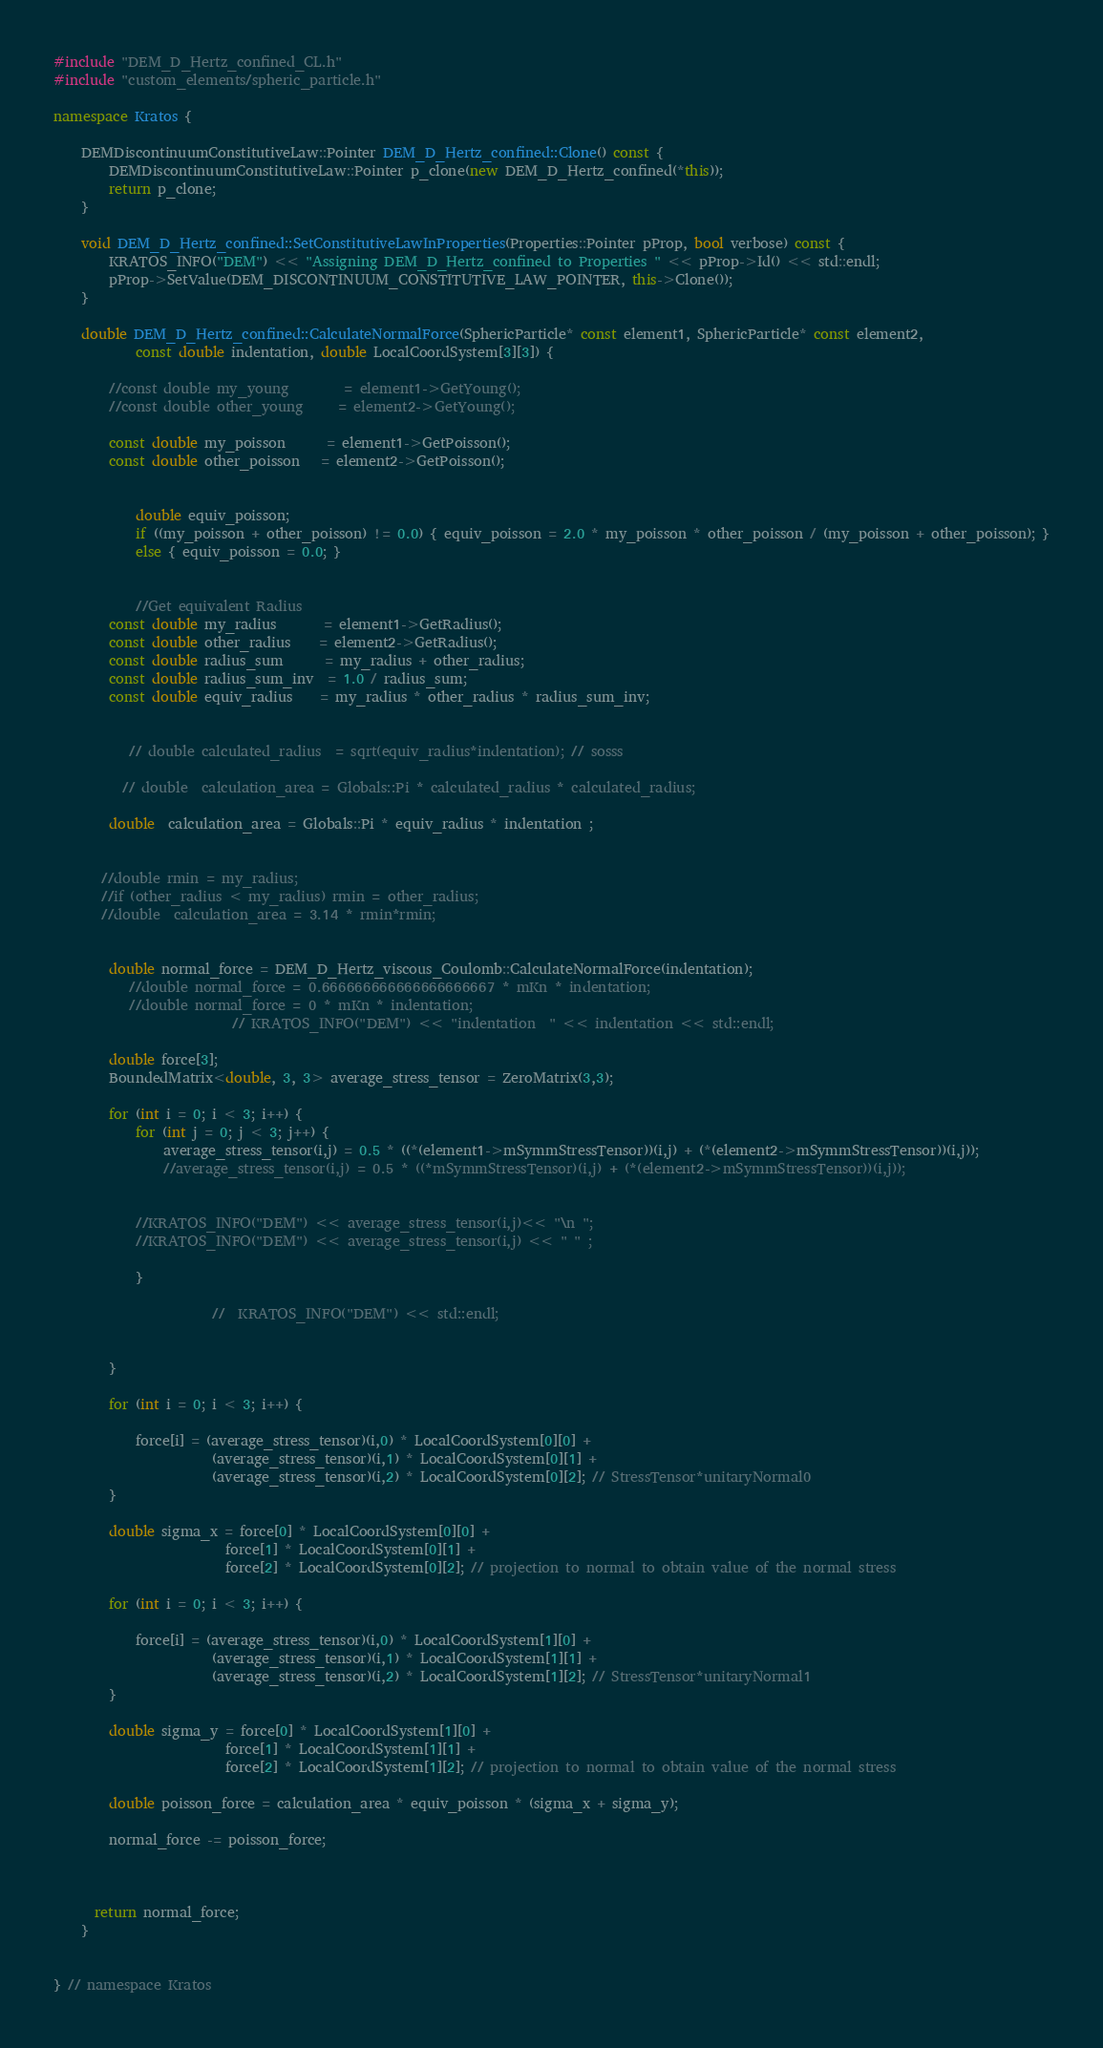Convert code to text. <code><loc_0><loc_0><loc_500><loc_500><_C++_>

#include "DEM_D_Hertz_confined_CL.h"
#include "custom_elements/spheric_particle.h"

namespace Kratos {

    DEMDiscontinuumConstitutiveLaw::Pointer DEM_D_Hertz_confined::Clone() const {
        DEMDiscontinuumConstitutiveLaw::Pointer p_clone(new DEM_D_Hertz_confined(*this));
        return p_clone;
    }

    void DEM_D_Hertz_confined::SetConstitutiveLawInProperties(Properties::Pointer pProp, bool verbose) const {
        KRATOS_INFO("DEM") << "Assigning DEM_D_Hertz_confined to Properties " << pProp->Id() << std::endl;
        pProp->SetValue(DEM_DISCONTINUUM_CONSTITUTIVE_LAW_POINTER, this->Clone());
    }

    double DEM_D_Hertz_confined::CalculateNormalForce(SphericParticle* const element1, SphericParticle* const element2,
            const double indentation, double LocalCoordSystem[3][3]) {

        //const double my_young        = element1->GetYoung();
        //const double other_young     = element2->GetYoung();

        const double my_poisson      = element1->GetPoisson();
        const double other_poisson   = element2->GetPoisson();


            double equiv_poisson;
            if ((my_poisson + other_poisson) != 0.0) { equiv_poisson = 2.0 * my_poisson * other_poisson / (my_poisson + other_poisson); }
            else { equiv_poisson = 0.0; }


            //Get equivalent Radius
        const double my_radius       = element1->GetRadius();
        const double other_radius    = element2->GetRadius();
        const double radius_sum      = my_radius + other_radius;
        const double radius_sum_inv  = 1.0 / radius_sum;
        const double equiv_radius    = my_radius * other_radius * radius_sum_inv;


           // double calculated_radius  = sqrt(equiv_radius*indentation); // sosss

          // double  calculation_area = Globals::Pi * calculated_radius * calculated_radius;

        double  calculation_area = Globals::Pi * equiv_radius * indentation ;


       //double rmin = my_radius;
       //if (other_radius < my_radius) rmin = other_radius;
       //double  calculation_area = 3.14 * rmin*rmin;


        double normal_force = DEM_D_Hertz_viscous_Coulomb::CalculateNormalForce(indentation);
           //double normal_force = 0.666666666666666666667 * mKn * indentation;
           //double normal_force = 0 * mKn * indentation;
                          // KRATOS_INFO("DEM") << "indentation  " << indentation << std::endl;

        double force[3];
        BoundedMatrix<double, 3, 3> average_stress_tensor = ZeroMatrix(3,3);

        for (int i = 0; i < 3; i++) {
            for (int j = 0; j < 3; j++) {
                average_stress_tensor(i,j) = 0.5 * ((*(element1->mSymmStressTensor))(i,j) + (*(element2->mSymmStressTensor))(i,j));
                //average_stress_tensor(i,j) = 0.5 * ((*mSymmStressTensor)(i,j) + (*(element2->mSymmStressTensor))(i,j));


            //KRATOS_INFO("DEM") << average_stress_tensor(i,j)<< "\n ";
            //KRATOS_INFO("DEM") << average_stress_tensor(i,j) << " " ;

            }

                       //  KRATOS_INFO("DEM") << std::endl;


        }

        for (int i = 0; i < 3; i++) {

            force[i] = (average_stress_tensor)(i,0) * LocalCoordSystem[0][0] +
                       (average_stress_tensor)(i,1) * LocalCoordSystem[0][1] +
                       (average_stress_tensor)(i,2) * LocalCoordSystem[0][2]; // StressTensor*unitaryNormal0
        }

        double sigma_x = force[0] * LocalCoordSystem[0][0] +
                         force[1] * LocalCoordSystem[0][1] +
                         force[2] * LocalCoordSystem[0][2]; // projection to normal to obtain value of the normal stress

        for (int i = 0; i < 3; i++) {

            force[i] = (average_stress_tensor)(i,0) * LocalCoordSystem[1][0] +
                       (average_stress_tensor)(i,1) * LocalCoordSystem[1][1] +
                       (average_stress_tensor)(i,2) * LocalCoordSystem[1][2]; // StressTensor*unitaryNormal1
        }

        double sigma_y = force[0] * LocalCoordSystem[1][0] +
                         force[1] * LocalCoordSystem[1][1] +
                         force[2] * LocalCoordSystem[1][2]; // projection to normal to obtain value of the normal stress

        double poisson_force = calculation_area * equiv_poisson * (sigma_x + sigma_y);

        normal_force -= poisson_force;



      return normal_force;
    }


} // namespace Kratos
</code> 